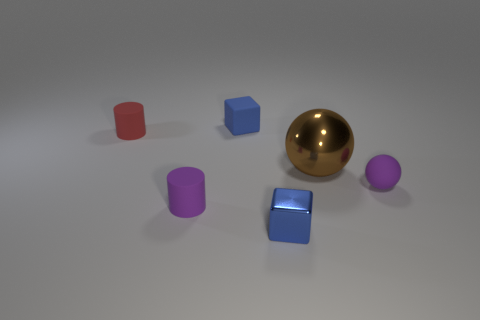Is there anything else that is the same size as the brown thing?
Provide a short and direct response. No. What is the size of the matte object that is both behind the big thing and on the right side of the tiny red rubber thing?
Ensure brevity in your answer.  Small. What material is the other cube that is the same color as the small matte block?
Offer a terse response. Metal. How many small metallic cubes are there?
Offer a very short reply. 1. Is the number of small blue metallic things less than the number of blocks?
Ensure brevity in your answer.  Yes. There is another blue thing that is the same size as the blue rubber thing; what is its material?
Offer a very short reply. Metal. What number of things are either tiny red matte things or brown metal things?
Offer a terse response. 2. What number of small rubber objects are both in front of the matte cube and behind the large brown thing?
Your answer should be compact. 1. Are there fewer small red matte cylinders that are in front of the purple cylinder than matte cubes?
Give a very brief answer. Yes. The red rubber thing that is the same size as the purple ball is what shape?
Provide a succinct answer. Cylinder. 